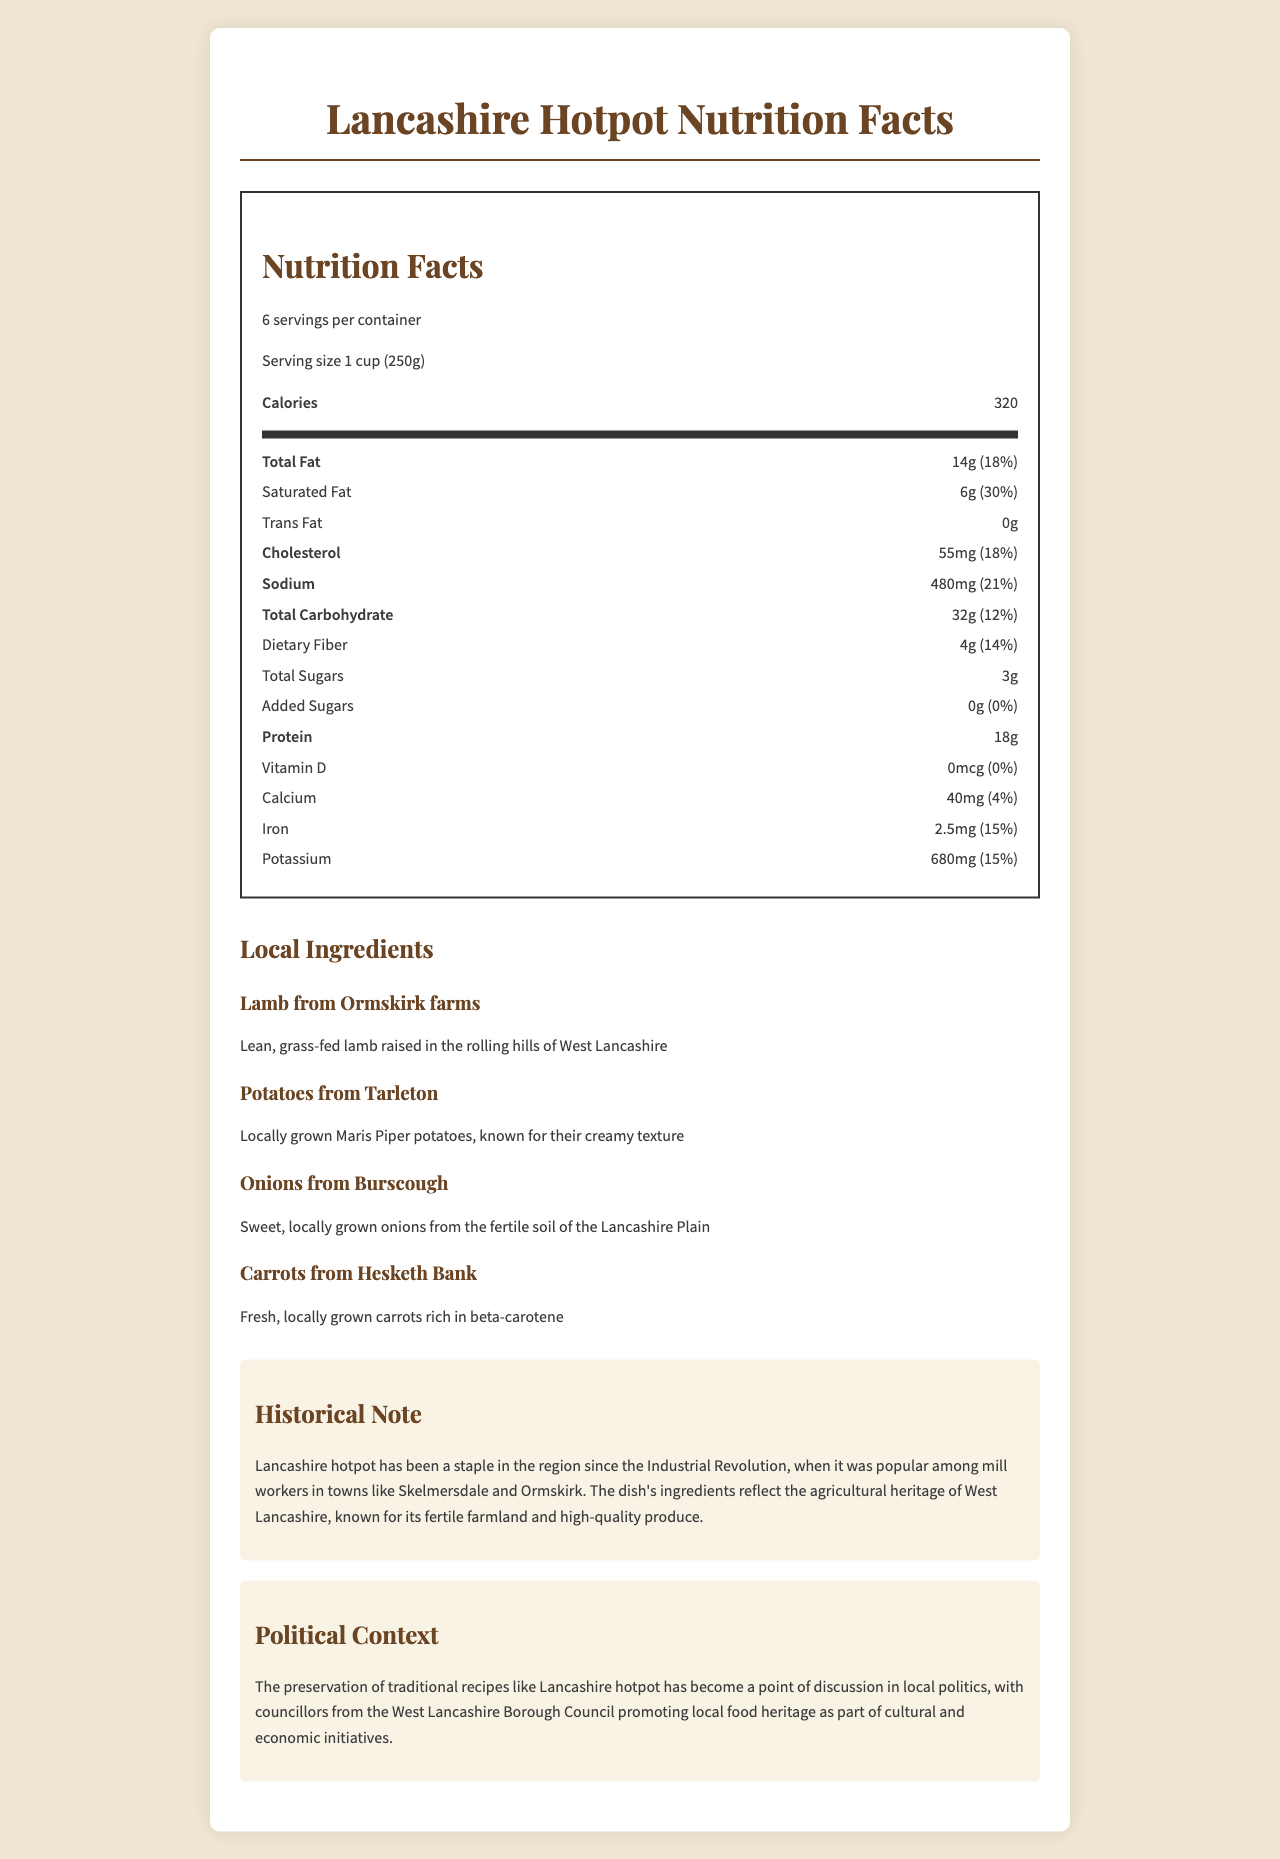who raised the lamb used in the Lancashire hotpot? The document mentions that the lamb is from Ormskirk farms, raised in the rolling hills of West Lancashire.
Answer: Ormskirk farms what is the serving size of the Lancashire hotpot? The document states that each serving size of the Lancashire hotpot is 1 cup or 250 grams.
Answer: 1 cup (250g) how many servings are in one container of Lancashire hotpot? The document specifies that there are 6 servings per container.
Answer: 6 how many grams of protein are in one serving of Lancashire hotpot? The document lists the protein content as 18 grams per serving.
Answer: 18 grams what percentage of daily value does saturated fat contribute to each serving of this hotpot? The document indicates that each serving contains 6 grams of saturated fat, contributing to 30% of the daily value.
Answer: 30% how much calcium does one serving of Lancashire hotpot provide? A. 0% B. 4% C. 10% D. 15% The document states that one serving provides 40 mg of calcium, which is 4% of the daily value.
Answer: B does the Lancashire hotpot contain any added sugars? The document specifies that there are 0 grams of added sugars in the hotpot.
Answer: No summarize the entire document. The explanation includes the detailed information present in the document, such as nutrition facts, local ingredients, historical context, and political implications.
Answer: The document provides nutrition facts for Lancashire hotpot, detailing the serving size, calories, and various nutrients. It highlights local ingredients sourced from different areas in West Lancashire, such as lamb from Ormskirk farms and potatoes from Tarleton. Additionally, there is a historical note on the hotpot's significance since the Industrial Revolution and its agricultural heritage. The document also mentions the political context, discussing local efforts to preserve traditional recipes as part of cultural and economic initiatives. what is the historical significance of Lancashire hotpot? The document asserts that Lancashire hotpot became a staple during the Industrial Revolution, particularly among mill workers in towns like Skelmersdale and Ormskirk.
Answer: It has been a staple since the Industrial Revolution, popular among mill workers. how many milligrams of sodium are in one serving of the hotpot? The document indicates that each serving contains 480 milligrams of sodium.
Answer: 480 mg what is the main message of the political context mentioned in the document? The document mentions that local councillors promote traditional recipes like the Lancashire hotpot to preserve local food heritage as part of cultural and economic initiatives.
Answer: Promotion of local food heritage through traditional recipes which local ingredient is known for being rich in beta-carotene? The document describes the carrots from Hesketh Bank as fresh and rich in beta-carotene.
Answer: Carrots from Hesketh Bank how does the document describe onions used in the hotpot? The document details that the onions are sweet and locally grown in the fertile soil of the Lancashire Plain.
Answer: Sweet, locally grown onions from the fertile soil of the Lancashire Plain how many grams of dietary fiber are in each serving of Lancashire hotpot? The document states that there are 4 grams of dietary fiber in each serving of the hotpot.
Answer: 4 grams what type of farms are mentioned as the source of lamb? The document specifies that the lamb used in the hotpot comes from Ormskirk farms.
Answer: Ormskirk farms does the hotpot contain any vitamin D? The document shows that there is 0 micrograms of vitamin D per serving.
Answer: No what is the fat content per serving of the Lancashire hotpot? The document indicates that each serving contains 14 grams of total fat.
Answer: 14 grams how many calories are there in one serving of Lancashire hotpot? The document states that one serving contains 320 calories.
Answer: 320 calories what type of potatoes are used in the hotpot? A. Maris Piper B. Russet C. King Edward D. Desiree The document mentions that Maris Piper potatoes from Tarleton are used in the hotpot.
Answer: A what are the main nutrients present in the Lancashire hotpot according to the nutrition facts? The document provides detailed nutrition facts listing contents like calories, various types of fats, cholesterol, sodium, carbohydrates, dietary fiber, sugars, protein, vitamin D, calcium, iron, and potassium.
Answer: Calories, fats, cholesterol, sodium, carbohydrates, dietary fiber, sugars, protein, vitamin D, calcium, iron, and potassium what is the description of the lamb used in the hotpot? The document describes the lamb as lean and grass-fed, raised in the rolling hills of West Lancashire.
Answer: Lean, grass-fed lamb raised in the rolling hills of West Lancashire which nutrient's daily value is not provided in the document? The document provides the amount of potassium but does not list its percentage of daily value.
Answer: Potassium is the preservation of traditional recipes like Lancashire hotpot discussed in the document? The document discusses local political efforts to promote traditional recipes like Lancashire hotpot to preserve local food heritage.
Answer: Yes 